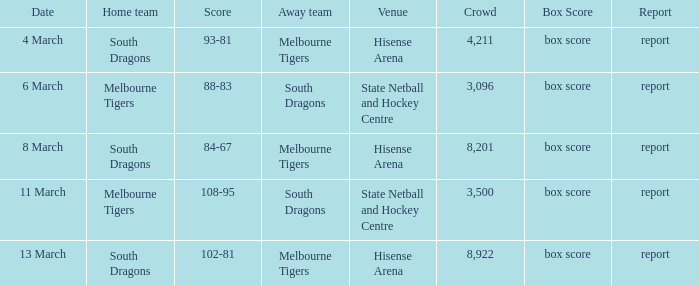In which venue did a gathering of 3,096 people take place, where the opposition was the melbourne tigers? Hisense Arena, Hisense Arena, Hisense Arena. 